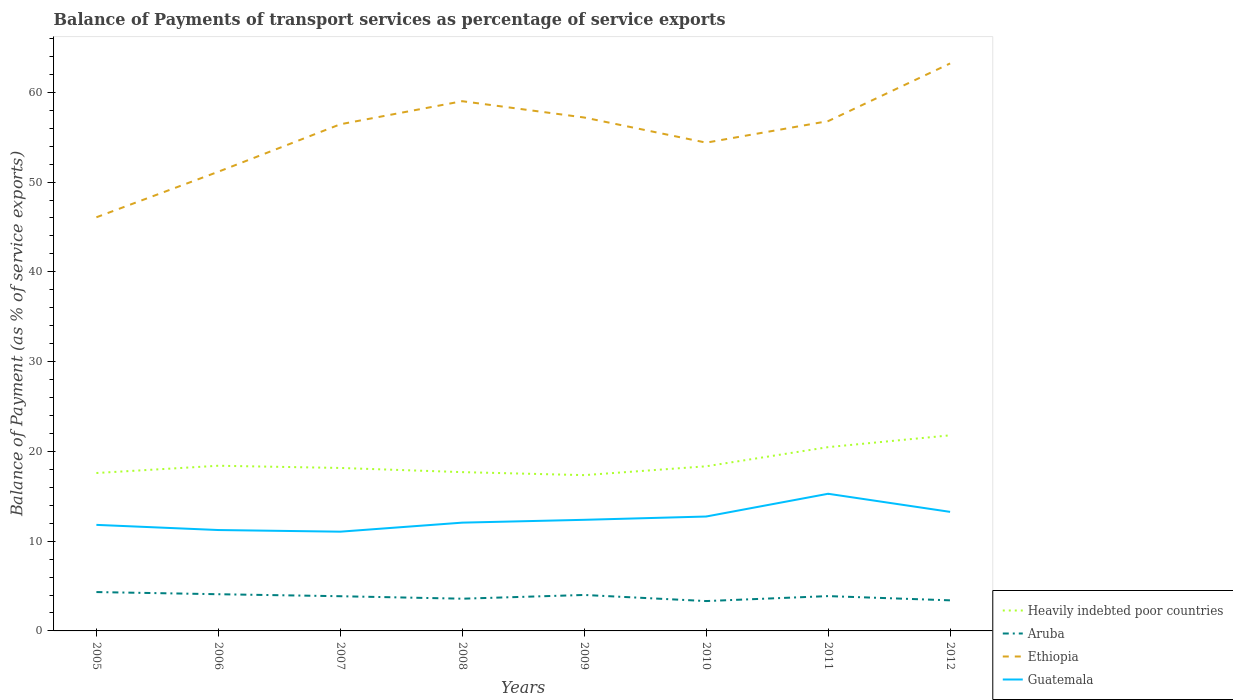Does the line corresponding to Guatemala intersect with the line corresponding to Heavily indebted poor countries?
Your answer should be very brief. No. Is the number of lines equal to the number of legend labels?
Your answer should be very brief. Yes. Across all years, what is the maximum balance of payments of transport services in Ethiopia?
Ensure brevity in your answer.  46.08. What is the total balance of payments of transport services in Aruba in the graph?
Make the answer very short. 0.08. What is the difference between the highest and the second highest balance of payments of transport services in Aruba?
Ensure brevity in your answer.  1. What is the difference between the highest and the lowest balance of payments of transport services in Guatemala?
Ensure brevity in your answer.  3. Is the balance of payments of transport services in Aruba strictly greater than the balance of payments of transport services in Ethiopia over the years?
Keep it short and to the point. Yes. What is the difference between two consecutive major ticks on the Y-axis?
Your answer should be compact. 10. Does the graph contain any zero values?
Offer a terse response. No. Where does the legend appear in the graph?
Keep it short and to the point. Bottom right. How are the legend labels stacked?
Offer a very short reply. Vertical. What is the title of the graph?
Your answer should be very brief. Balance of Payments of transport services as percentage of service exports. Does "Sweden" appear as one of the legend labels in the graph?
Keep it short and to the point. No. What is the label or title of the X-axis?
Keep it short and to the point. Years. What is the label or title of the Y-axis?
Your response must be concise. Balance of Payment (as % of service exports). What is the Balance of Payment (as % of service exports) in Heavily indebted poor countries in 2005?
Offer a very short reply. 17.59. What is the Balance of Payment (as % of service exports) of Aruba in 2005?
Keep it short and to the point. 4.33. What is the Balance of Payment (as % of service exports) of Ethiopia in 2005?
Make the answer very short. 46.08. What is the Balance of Payment (as % of service exports) of Guatemala in 2005?
Provide a succinct answer. 11.81. What is the Balance of Payment (as % of service exports) in Heavily indebted poor countries in 2006?
Give a very brief answer. 18.4. What is the Balance of Payment (as % of service exports) of Aruba in 2006?
Your answer should be very brief. 4.09. What is the Balance of Payment (as % of service exports) in Ethiopia in 2006?
Your answer should be compact. 51.16. What is the Balance of Payment (as % of service exports) in Guatemala in 2006?
Offer a very short reply. 11.24. What is the Balance of Payment (as % of service exports) in Heavily indebted poor countries in 2007?
Offer a terse response. 18.15. What is the Balance of Payment (as % of service exports) of Aruba in 2007?
Keep it short and to the point. 3.87. What is the Balance of Payment (as % of service exports) in Ethiopia in 2007?
Your response must be concise. 56.44. What is the Balance of Payment (as % of service exports) in Guatemala in 2007?
Give a very brief answer. 11.06. What is the Balance of Payment (as % of service exports) of Heavily indebted poor countries in 2008?
Give a very brief answer. 17.69. What is the Balance of Payment (as % of service exports) of Aruba in 2008?
Your answer should be compact. 3.59. What is the Balance of Payment (as % of service exports) of Ethiopia in 2008?
Offer a terse response. 59.01. What is the Balance of Payment (as % of service exports) in Guatemala in 2008?
Provide a short and direct response. 12.06. What is the Balance of Payment (as % of service exports) in Heavily indebted poor countries in 2009?
Your answer should be very brief. 17.36. What is the Balance of Payment (as % of service exports) of Aruba in 2009?
Your answer should be compact. 4.01. What is the Balance of Payment (as % of service exports) of Ethiopia in 2009?
Ensure brevity in your answer.  57.19. What is the Balance of Payment (as % of service exports) in Guatemala in 2009?
Offer a terse response. 12.38. What is the Balance of Payment (as % of service exports) of Heavily indebted poor countries in 2010?
Make the answer very short. 18.34. What is the Balance of Payment (as % of service exports) in Aruba in 2010?
Your response must be concise. 3.33. What is the Balance of Payment (as % of service exports) of Ethiopia in 2010?
Provide a succinct answer. 54.39. What is the Balance of Payment (as % of service exports) in Guatemala in 2010?
Your response must be concise. 12.74. What is the Balance of Payment (as % of service exports) of Heavily indebted poor countries in 2011?
Ensure brevity in your answer.  20.48. What is the Balance of Payment (as % of service exports) of Aruba in 2011?
Provide a succinct answer. 3.88. What is the Balance of Payment (as % of service exports) of Ethiopia in 2011?
Your response must be concise. 56.79. What is the Balance of Payment (as % of service exports) of Guatemala in 2011?
Your answer should be very brief. 15.28. What is the Balance of Payment (as % of service exports) of Heavily indebted poor countries in 2012?
Keep it short and to the point. 21.79. What is the Balance of Payment (as % of service exports) in Aruba in 2012?
Ensure brevity in your answer.  3.41. What is the Balance of Payment (as % of service exports) of Ethiopia in 2012?
Ensure brevity in your answer.  63.22. What is the Balance of Payment (as % of service exports) of Guatemala in 2012?
Provide a short and direct response. 13.26. Across all years, what is the maximum Balance of Payment (as % of service exports) in Heavily indebted poor countries?
Ensure brevity in your answer.  21.79. Across all years, what is the maximum Balance of Payment (as % of service exports) in Aruba?
Keep it short and to the point. 4.33. Across all years, what is the maximum Balance of Payment (as % of service exports) of Ethiopia?
Give a very brief answer. 63.22. Across all years, what is the maximum Balance of Payment (as % of service exports) in Guatemala?
Give a very brief answer. 15.28. Across all years, what is the minimum Balance of Payment (as % of service exports) in Heavily indebted poor countries?
Offer a terse response. 17.36. Across all years, what is the minimum Balance of Payment (as % of service exports) of Aruba?
Ensure brevity in your answer.  3.33. Across all years, what is the minimum Balance of Payment (as % of service exports) in Ethiopia?
Give a very brief answer. 46.08. Across all years, what is the minimum Balance of Payment (as % of service exports) in Guatemala?
Provide a short and direct response. 11.06. What is the total Balance of Payment (as % of service exports) in Heavily indebted poor countries in the graph?
Ensure brevity in your answer.  149.8. What is the total Balance of Payment (as % of service exports) in Aruba in the graph?
Ensure brevity in your answer.  30.49. What is the total Balance of Payment (as % of service exports) of Ethiopia in the graph?
Offer a very short reply. 444.28. What is the total Balance of Payment (as % of service exports) in Guatemala in the graph?
Offer a very short reply. 99.83. What is the difference between the Balance of Payment (as % of service exports) of Heavily indebted poor countries in 2005 and that in 2006?
Your answer should be very brief. -0.81. What is the difference between the Balance of Payment (as % of service exports) of Aruba in 2005 and that in 2006?
Offer a very short reply. 0.24. What is the difference between the Balance of Payment (as % of service exports) of Ethiopia in 2005 and that in 2006?
Your response must be concise. -5.08. What is the difference between the Balance of Payment (as % of service exports) of Guatemala in 2005 and that in 2006?
Make the answer very short. 0.58. What is the difference between the Balance of Payment (as % of service exports) in Heavily indebted poor countries in 2005 and that in 2007?
Provide a short and direct response. -0.56. What is the difference between the Balance of Payment (as % of service exports) in Aruba in 2005 and that in 2007?
Offer a terse response. 0.46. What is the difference between the Balance of Payment (as % of service exports) in Ethiopia in 2005 and that in 2007?
Keep it short and to the point. -10.36. What is the difference between the Balance of Payment (as % of service exports) in Guatemala in 2005 and that in 2007?
Your answer should be very brief. 0.76. What is the difference between the Balance of Payment (as % of service exports) of Heavily indebted poor countries in 2005 and that in 2008?
Provide a succinct answer. -0.1. What is the difference between the Balance of Payment (as % of service exports) of Aruba in 2005 and that in 2008?
Provide a short and direct response. 0.74. What is the difference between the Balance of Payment (as % of service exports) of Ethiopia in 2005 and that in 2008?
Offer a terse response. -12.93. What is the difference between the Balance of Payment (as % of service exports) of Guatemala in 2005 and that in 2008?
Ensure brevity in your answer.  -0.25. What is the difference between the Balance of Payment (as % of service exports) in Heavily indebted poor countries in 2005 and that in 2009?
Provide a short and direct response. 0.24. What is the difference between the Balance of Payment (as % of service exports) in Aruba in 2005 and that in 2009?
Your response must be concise. 0.32. What is the difference between the Balance of Payment (as % of service exports) in Ethiopia in 2005 and that in 2009?
Your answer should be very brief. -11.12. What is the difference between the Balance of Payment (as % of service exports) of Guatemala in 2005 and that in 2009?
Provide a succinct answer. -0.56. What is the difference between the Balance of Payment (as % of service exports) of Heavily indebted poor countries in 2005 and that in 2010?
Make the answer very short. -0.75. What is the difference between the Balance of Payment (as % of service exports) of Aruba in 2005 and that in 2010?
Provide a succinct answer. 1. What is the difference between the Balance of Payment (as % of service exports) in Ethiopia in 2005 and that in 2010?
Make the answer very short. -8.31. What is the difference between the Balance of Payment (as % of service exports) of Guatemala in 2005 and that in 2010?
Your answer should be very brief. -0.93. What is the difference between the Balance of Payment (as % of service exports) of Heavily indebted poor countries in 2005 and that in 2011?
Offer a very short reply. -2.88. What is the difference between the Balance of Payment (as % of service exports) in Aruba in 2005 and that in 2011?
Offer a very short reply. 0.45. What is the difference between the Balance of Payment (as % of service exports) of Ethiopia in 2005 and that in 2011?
Make the answer very short. -10.71. What is the difference between the Balance of Payment (as % of service exports) of Guatemala in 2005 and that in 2011?
Offer a terse response. -3.47. What is the difference between the Balance of Payment (as % of service exports) in Heavily indebted poor countries in 2005 and that in 2012?
Keep it short and to the point. -4.2. What is the difference between the Balance of Payment (as % of service exports) of Aruba in 2005 and that in 2012?
Offer a very short reply. 0.92. What is the difference between the Balance of Payment (as % of service exports) in Ethiopia in 2005 and that in 2012?
Your answer should be very brief. -17.14. What is the difference between the Balance of Payment (as % of service exports) of Guatemala in 2005 and that in 2012?
Make the answer very short. -1.45. What is the difference between the Balance of Payment (as % of service exports) of Heavily indebted poor countries in 2006 and that in 2007?
Your answer should be very brief. 0.25. What is the difference between the Balance of Payment (as % of service exports) in Aruba in 2006 and that in 2007?
Your answer should be compact. 0.22. What is the difference between the Balance of Payment (as % of service exports) of Ethiopia in 2006 and that in 2007?
Make the answer very short. -5.29. What is the difference between the Balance of Payment (as % of service exports) of Guatemala in 2006 and that in 2007?
Your answer should be compact. 0.18. What is the difference between the Balance of Payment (as % of service exports) of Heavily indebted poor countries in 2006 and that in 2008?
Provide a succinct answer. 0.71. What is the difference between the Balance of Payment (as % of service exports) in Aruba in 2006 and that in 2008?
Your answer should be very brief. 0.5. What is the difference between the Balance of Payment (as % of service exports) of Ethiopia in 2006 and that in 2008?
Ensure brevity in your answer.  -7.86. What is the difference between the Balance of Payment (as % of service exports) in Guatemala in 2006 and that in 2008?
Your response must be concise. -0.82. What is the difference between the Balance of Payment (as % of service exports) in Heavily indebted poor countries in 2006 and that in 2009?
Provide a short and direct response. 1.05. What is the difference between the Balance of Payment (as % of service exports) in Aruba in 2006 and that in 2009?
Make the answer very short. 0.08. What is the difference between the Balance of Payment (as % of service exports) in Ethiopia in 2006 and that in 2009?
Ensure brevity in your answer.  -6.04. What is the difference between the Balance of Payment (as % of service exports) of Guatemala in 2006 and that in 2009?
Make the answer very short. -1.14. What is the difference between the Balance of Payment (as % of service exports) in Heavily indebted poor countries in 2006 and that in 2010?
Make the answer very short. 0.06. What is the difference between the Balance of Payment (as % of service exports) in Aruba in 2006 and that in 2010?
Offer a very short reply. 0.76. What is the difference between the Balance of Payment (as % of service exports) in Ethiopia in 2006 and that in 2010?
Give a very brief answer. -3.24. What is the difference between the Balance of Payment (as % of service exports) in Guatemala in 2006 and that in 2010?
Provide a short and direct response. -1.51. What is the difference between the Balance of Payment (as % of service exports) in Heavily indebted poor countries in 2006 and that in 2011?
Your answer should be very brief. -2.07. What is the difference between the Balance of Payment (as % of service exports) in Aruba in 2006 and that in 2011?
Make the answer very short. 0.21. What is the difference between the Balance of Payment (as % of service exports) in Ethiopia in 2006 and that in 2011?
Offer a very short reply. -5.64. What is the difference between the Balance of Payment (as % of service exports) of Guatemala in 2006 and that in 2011?
Provide a succinct answer. -4.04. What is the difference between the Balance of Payment (as % of service exports) in Heavily indebted poor countries in 2006 and that in 2012?
Offer a terse response. -3.39. What is the difference between the Balance of Payment (as % of service exports) of Aruba in 2006 and that in 2012?
Provide a succinct answer. 0.68. What is the difference between the Balance of Payment (as % of service exports) of Ethiopia in 2006 and that in 2012?
Offer a very short reply. -12.06. What is the difference between the Balance of Payment (as % of service exports) in Guatemala in 2006 and that in 2012?
Your answer should be compact. -2.02. What is the difference between the Balance of Payment (as % of service exports) in Heavily indebted poor countries in 2007 and that in 2008?
Your answer should be very brief. 0.47. What is the difference between the Balance of Payment (as % of service exports) in Aruba in 2007 and that in 2008?
Offer a terse response. 0.28. What is the difference between the Balance of Payment (as % of service exports) in Ethiopia in 2007 and that in 2008?
Provide a succinct answer. -2.57. What is the difference between the Balance of Payment (as % of service exports) in Guatemala in 2007 and that in 2008?
Your answer should be compact. -1.01. What is the difference between the Balance of Payment (as % of service exports) in Heavily indebted poor countries in 2007 and that in 2009?
Ensure brevity in your answer.  0.8. What is the difference between the Balance of Payment (as % of service exports) in Aruba in 2007 and that in 2009?
Make the answer very short. -0.14. What is the difference between the Balance of Payment (as % of service exports) in Ethiopia in 2007 and that in 2009?
Give a very brief answer. -0.75. What is the difference between the Balance of Payment (as % of service exports) of Guatemala in 2007 and that in 2009?
Ensure brevity in your answer.  -1.32. What is the difference between the Balance of Payment (as % of service exports) of Heavily indebted poor countries in 2007 and that in 2010?
Your response must be concise. -0.18. What is the difference between the Balance of Payment (as % of service exports) in Aruba in 2007 and that in 2010?
Provide a succinct answer. 0.54. What is the difference between the Balance of Payment (as % of service exports) of Ethiopia in 2007 and that in 2010?
Your answer should be very brief. 2.05. What is the difference between the Balance of Payment (as % of service exports) of Guatemala in 2007 and that in 2010?
Your response must be concise. -1.69. What is the difference between the Balance of Payment (as % of service exports) of Heavily indebted poor countries in 2007 and that in 2011?
Provide a short and direct response. -2.32. What is the difference between the Balance of Payment (as % of service exports) of Aruba in 2007 and that in 2011?
Your response must be concise. -0.01. What is the difference between the Balance of Payment (as % of service exports) of Ethiopia in 2007 and that in 2011?
Give a very brief answer. -0.35. What is the difference between the Balance of Payment (as % of service exports) of Guatemala in 2007 and that in 2011?
Provide a short and direct response. -4.22. What is the difference between the Balance of Payment (as % of service exports) in Heavily indebted poor countries in 2007 and that in 2012?
Make the answer very short. -3.64. What is the difference between the Balance of Payment (as % of service exports) in Aruba in 2007 and that in 2012?
Your response must be concise. 0.46. What is the difference between the Balance of Payment (as % of service exports) in Ethiopia in 2007 and that in 2012?
Provide a succinct answer. -6.77. What is the difference between the Balance of Payment (as % of service exports) in Guatemala in 2007 and that in 2012?
Your answer should be compact. -2.21. What is the difference between the Balance of Payment (as % of service exports) of Heavily indebted poor countries in 2008 and that in 2009?
Provide a short and direct response. 0.33. What is the difference between the Balance of Payment (as % of service exports) in Aruba in 2008 and that in 2009?
Give a very brief answer. -0.42. What is the difference between the Balance of Payment (as % of service exports) in Ethiopia in 2008 and that in 2009?
Provide a short and direct response. 1.82. What is the difference between the Balance of Payment (as % of service exports) of Guatemala in 2008 and that in 2009?
Keep it short and to the point. -0.31. What is the difference between the Balance of Payment (as % of service exports) in Heavily indebted poor countries in 2008 and that in 2010?
Provide a succinct answer. -0.65. What is the difference between the Balance of Payment (as % of service exports) in Aruba in 2008 and that in 2010?
Ensure brevity in your answer.  0.26. What is the difference between the Balance of Payment (as % of service exports) in Ethiopia in 2008 and that in 2010?
Provide a short and direct response. 4.62. What is the difference between the Balance of Payment (as % of service exports) in Guatemala in 2008 and that in 2010?
Your response must be concise. -0.68. What is the difference between the Balance of Payment (as % of service exports) of Heavily indebted poor countries in 2008 and that in 2011?
Make the answer very short. -2.79. What is the difference between the Balance of Payment (as % of service exports) in Aruba in 2008 and that in 2011?
Your answer should be compact. -0.29. What is the difference between the Balance of Payment (as % of service exports) of Ethiopia in 2008 and that in 2011?
Your response must be concise. 2.22. What is the difference between the Balance of Payment (as % of service exports) of Guatemala in 2008 and that in 2011?
Provide a succinct answer. -3.22. What is the difference between the Balance of Payment (as % of service exports) in Heavily indebted poor countries in 2008 and that in 2012?
Provide a succinct answer. -4.1. What is the difference between the Balance of Payment (as % of service exports) in Aruba in 2008 and that in 2012?
Provide a short and direct response. 0.18. What is the difference between the Balance of Payment (as % of service exports) of Ethiopia in 2008 and that in 2012?
Ensure brevity in your answer.  -4.2. What is the difference between the Balance of Payment (as % of service exports) of Guatemala in 2008 and that in 2012?
Keep it short and to the point. -1.2. What is the difference between the Balance of Payment (as % of service exports) in Heavily indebted poor countries in 2009 and that in 2010?
Your response must be concise. -0.98. What is the difference between the Balance of Payment (as % of service exports) of Aruba in 2009 and that in 2010?
Provide a short and direct response. 0.68. What is the difference between the Balance of Payment (as % of service exports) in Ethiopia in 2009 and that in 2010?
Your answer should be very brief. 2.8. What is the difference between the Balance of Payment (as % of service exports) in Guatemala in 2009 and that in 2010?
Keep it short and to the point. -0.37. What is the difference between the Balance of Payment (as % of service exports) of Heavily indebted poor countries in 2009 and that in 2011?
Make the answer very short. -3.12. What is the difference between the Balance of Payment (as % of service exports) of Aruba in 2009 and that in 2011?
Keep it short and to the point. 0.13. What is the difference between the Balance of Payment (as % of service exports) of Ethiopia in 2009 and that in 2011?
Your answer should be compact. 0.4. What is the difference between the Balance of Payment (as % of service exports) of Guatemala in 2009 and that in 2011?
Your answer should be compact. -2.9. What is the difference between the Balance of Payment (as % of service exports) in Heavily indebted poor countries in 2009 and that in 2012?
Offer a very short reply. -4.43. What is the difference between the Balance of Payment (as % of service exports) of Aruba in 2009 and that in 2012?
Make the answer very short. 0.6. What is the difference between the Balance of Payment (as % of service exports) of Ethiopia in 2009 and that in 2012?
Make the answer very short. -6.02. What is the difference between the Balance of Payment (as % of service exports) of Guatemala in 2009 and that in 2012?
Your answer should be compact. -0.89. What is the difference between the Balance of Payment (as % of service exports) in Heavily indebted poor countries in 2010 and that in 2011?
Your answer should be very brief. -2.14. What is the difference between the Balance of Payment (as % of service exports) in Aruba in 2010 and that in 2011?
Ensure brevity in your answer.  -0.55. What is the difference between the Balance of Payment (as % of service exports) of Ethiopia in 2010 and that in 2011?
Provide a short and direct response. -2.4. What is the difference between the Balance of Payment (as % of service exports) of Guatemala in 2010 and that in 2011?
Provide a short and direct response. -2.53. What is the difference between the Balance of Payment (as % of service exports) in Heavily indebted poor countries in 2010 and that in 2012?
Offer a terse response. -3.45. What is the difference between the Balance of Payment (as % of service exports) in Aruba in 2010 and that in 2012?
Offer a very short reply. -0.08. What is the difference between the Balance of Payment (as % of service exports) of Ethiopia in 2010 and that in 2012?
Your response must be concise. -8.82. What is the difference between the Balance of Payment (as % of service exports) in Guatemala in 2010 and that in 2012?
Your answer should be very brief. -0.52. What is the difference between the Balance of Payment (as % of service exports) of Heavily indebted poor countries in 2011 and that in 2012?
Make the answer very short. -1.31. What is the difference between the Balance of Payment (as % of service exports) of Aruba in 2011 and that in 2012?
Give a very brief answer. 0.47. What is the difference between the Balance of Payment (as % of service exports) in Ethiopia in 2011 and that in 2012?
Give a very brief answer. -6.42. What is the difference between the Balance of Payment (as % of service exports) in Guatemala in 2011 and that in 2012?
Offer a very short reply. 2.02. What is the difference between the Balance of Payment (as % of service exports) of Heavily indebted poor countries in 2005 and the Balance of Payment (as % of service exports) of Aruba in 2006?
Your response must be concise. 13.5. What is the difference between the Balance of Payment (as % of service exports) of Heavily indebted poor countries in 2005 and the Balance of Payment (as % of service exports) of Ethiopia in 2006?
Make the answer very short. -33.56. What is the difference between the Balance of Payment (as % of service exports) in Heavily indebted poor countries in 2005 and the Balance of Payment (as % of service exports) in Guatemala in 2006?
Your response must be concise. 6.35. What is the difference between the Balance of Payment (as % of service exports) of Aruba in 2005 and the Balance of Payment (as % of service exports) of Ethiopia in 2006?
Your response must be concise. -46.83. What is the difference between the Balance of Payment (as % of service exports) of Aruba in 2005 and the Balance of Payment (as % of service exports) of Guatemala in 2006?
Your response must be concise. -6.91. What is the difference between the Balance of Payment (as % of service exports) in Ethiopia in 2005 and the Balance of Payment (as % of service exports) in Guatemala in 2006?
Provide a succinct answer. 34.84. What is the difference between the Balance of Payment (as % of service exports) in Heavily indebted poor countries in 2005 and the Balance of Payment (as % of service exports) in Aruba in 2007?
Keep it short and to the point. 13.73. What is the difference between the Balance of Payment (as % of service exports) in Heavily indebted poor countries in 2005 and the Balance of Payment (as % of service exports) in Ethiopia in 2007?
Offer a terse response. -38.85. What is the difference between the Balance of Payment (as % of service exports) of Heavily indebted poor countries in 2005 and the Balance of Payment (as % of service exports) of Guatemala in 2007?
Your response must be concise. 6.53. What is the difference between the Balance of Payment (as % of service exports) of Aruba in 2005 and the Balance of Payment (as % of service exports) of Ethiopia in 2007?
Make the answer very short. -52.11. What is the difference between the Balance of Payment (as % of service exports) in Aruba in 2005 and the Balance of Payment (as % of service exports) in Guatemala in 2007?
Keep it short and to the point. -6.73. What is the difference between the Balance of Payment (as % of service exports) of Ethiopia in 2005 and the Balance of Payment (as % of service exports) of Guatemala in 2007?
Make the answer very short. 35.02. What is the difference between the Balance of Payment (as % of service exports) in Heavily indebted poor countries in 2005 and the Balance of Payment (as % of service exports) in Aruba in 2008?
Your response must be concise. 14. What is the difference between the Balance of Payment (as % of service exports) of Heavily indebted poor countries in 2005 and the Balance of Payment (as % of service exports) of Ethiopia in 2008?
Keep it short and to the point. -41.42. What is the difference between the Balance of Payment (as % of service exports) of Heavily indebted poor countries in 2005 and the Balance of Payment (as % of service exports) of Guatemala in 2008?
Provide a succinct answer. 5.53. What is the difference between the Balance of Payment (as % of service exports) of Aruba in 2005 and the Balance of Payment (as % of service exports) of Ethiopia in 2008?
Your answer should be compact. -54.68. What is the difference between the Balance of Payment (as % of service exports) in Aruba in 2005 and the Balance of Payment (as % of service exports) in Guatemala in 2008?
Ensure brevity in your answer.  -7.73. What is the difference between the Balance of Payment (as % of service exports) in Ethiopia in 2005 and the Balance of Payment (as % of service exports) in Guatemala in 2008?
Offer a terse response. 34.02. What is the difference between the Balance of Payment (as % of service exports) of Heavily indebted poor countries in 2005 and the Balance of Payment (as % of service exports) of Aruba in 2009?
Give a very brief answer. 13.58. What is the difference between the Balance of Payment (as % of service exports) of Heavily indebted poor countries in 2005 and the Balance of Payment (as % of service exports) of Ethiopia in 2009?
Give a very brief answer. -39.6. What is the difference between the Balance of Payment (as % of service exports) in Heavily indebted poor countries in 2005 and the Balance of Payment (as % of service exports) in Guatemala in 2009?
Offer a terse response. 5.21. What is the difference between the Balance of Payment (as % of service exports) of Aruba in 2005 and the Balance of Payment (as % of service exports) of Ethiopia in 2009?
Ensure brevity in your answer.  -52.87. What is the difference between the Balance of Payment (as % of service exports) in Aruba in 2005 and the Balance of Payment (as % of service exports) in Guatemala in 2009?
Give a very brief answer. -8.05. What is the difference between the Balance of Payment (as % of service exports) of Ethiopia in 2005 and the Balance of Payment (as % of service exports) of Guatemala in 2009?
Keep it short and to the point. 33.7. What is the difference between the Balance of Payment (as % of service exports) in Heavily indebted poor countries in 2005 and the Balance of Payment (as % of service exports) in Aruba in 2010?
Make the answer very short. 14.26. What is the difference between the Balance of Payment (as % of service exports) of Heavily indebted poor countries in 2005 and the Balance of Payment (as % of service exports) of Ethiopia in 2010?
Provide a succinct answer. -36.8. What is the difference between the Balance of Payment (as % of service exports) in Heavily indebted poor countries in 2005 and the Balance of Payment (as % of service exports) in Guatemala in 2010?
Keep it short and to the point. 4.85. What is the difference between the Balance of Payment (as % of service exports) of Aruba in 2005 and the Balance of Payment (as % of service exports) of Ethiopia in 2010?
Your response must be concise. -50.06. What is the difference between the Balance of Payment (as % of service exports) of Aruba in 2005 and the Balance of Payment (as % of service exports) of Guatemala in 2010?
Your answer should be very brief. -8.42. What is the difference between the Balance of Payment (as % of service exports) in Ethiopia in 2005 and the Balance of Payment (as % of service exports) in Guatemala in 2010?
Provide a succinct answer. 33.33. What is the difference between the Balance of Payment (as % of service exports) in Heavily indebted poor countries in 2005 and the Balance of Payment (as % of service exports) in Aruba in 2011?
Ensure brevity in your answer.  13.71. What is the difference between the Balance of Payment (as % of service exports) of Heavily indebted poor countries in 2005 and the Balance of Payment (as % of service exports) of Ethiopia in 2011?
Give a very brief answer. -39.2. What is the difference between the Balance of Payment (as % of service exports) in Heavily indebted poor countries in 2005 and the Balance of Payment (as % of service exports) in Guatemala in 2011?
Make the answer very short. 2.31. What is the difference between the Balance of Payment (as % of service exports) in Aruba in 2005 and the Balance of Payment (as % of service exports) in Ethiopia in 2011?
Offer a terse response. -52.46. What is the difference between the Balance of Payment (as % of service exports) in Aruba in 2005 and the Balance of Payment (as % of service exports) in Guatemala in 2011?
Ensure brevity in your answer.  -10.95. What is the difference between the Balance of Payment (as % of service exports) in Ethiopia in 2005 and the Balance of Payment (as % of service exports) in Guatemala in 2011?
Provide a short and direct response. 30.8. What is the difference between the Balance of Payment (as % of service exports) in Heavily indebted poor countries in 2005 and the Balance of Payment (as % of service exports) in Aruba in 2012?
Your answer should be compact. 14.18. What is the difference between the Balance of Payment (as % of service exports) in Heavily indebted poor countries in 2005 and the Balance of Payment (as % of service exports) in Ethiopia in 2012?
Keep it short and to the point. -45.62. What is the difference between the Balance of Payment (as % of service exports) of Heavily indebted poor countries in 2005 and the Balance of Payment (as % of service exports) of Guatemala in 2012?
Your response must be concise. 4.33. What is the difference between the Balance of Payment (as % of service exports) in Aruba in 2005 and the Balance of Payment (as % of service exports) in Ethiopia in 2012?
Provide a short and direct response. -58.89. What is the difference between the Balance of Payment (as % of service exports) in Aruba in 2005 and the Balance of Payment (as % of service exports) in Guatemala in 2012?
Give a very brief answer. -8.93. What is the difference between the Balance of Payment (as % of service exports) of Ethiopia in 2005 and the Balance of Payment (as % of service exports) of Guatemala in 2012?
Keep it short and to the point. 32.82. What is the difference between the Balance of Payment (as % of service exports) in Heavily indebted poor countries in 2006 and the Balance of Payment (as % of service exports) in Aruba in 2007?
Give a very brief answer. 14.54. What is the difference between the Balance of Payment (as % of service exports) in Heavily indebted poor countries in 2006 and the Balance of Payment (as % of service exports) in Ethiopia in 2007?
Give a very brief answer. -38.04. What is the difference between the Balance of Payment (as % of service exports) in Heavily indebted poor countries in 2006 and the Balance of Payment (as % of service exports) in Guatemala in 2007?
Offer a very short reply. 7.35. What is the difference between the Balance of Payment (as % of service exports) of Aruba in 2006 and the Balance of Payment (as % of service exports) of Ethiopia in 2007?
Provide a short and direct response. -52.35. What is the difference between the Balance of Payment (as % of service exports) in Aruba in 2006 and the Balance of Payment (as % of service exports) in Guatemala in 2007?
Keep it short and to the point. -6.97. What is the difference between the Balance of Payment (as % of service exports) of Ethiopia in 2006 and the Balance of Payment (as % of service exports) of Guatemala in 2007?
Your answer should be compact. 40.1. What is the difference between the Balance of Payment (as % of service exports) in Heavily indebted poor countries in 2006 and the Balance of Payment (as % of service exports) in Aruba in 2008?
Your response must be concise. 14.81. What is the difference between the Balance of Payment (as % of service exports) of Heavily indebted poor countries in 2006 and the Balance of Payment (as % of service exports) of Ethiopia in 2008?
Your answer should be compact. -40.61. What is the difference between the Balance of Payment (as % of service exports) of Heavily indebted poor countries in 2006 and the Balance of Payment (as % of service exports) of Guatemala in 2008?
Keep it short and to the point. 6.34. What is the difference between the Balance of Payment (as % of service exports) in Aruba in 2006 and the Balance of Payment (as % of service exports) in Ethiopia in 2008?
Your answer should be very brief. -54.92. What is the difference between the Balance of Payment (as % of service exports) in Aruba in 2006 and the Balance of Payment (as % of service exports) in Guatemala in 2008?
Ensure brevity in your answer.  -7.97. What is the difference between the Balance of Payment (as % of service exports) of Ethiopia in 2006 and the Balance of Payment (as % of service exports) of Guatemala in 2008?
Provide a short and direct response. 39.09. What is the difference between the Balance of Payment (as % of service exports) of Heavily indebted poor countries in 2006 and the Balance of Payment (as % of service exports) of Aruba in 2009?
Make the answer very short. 14.4. What is the difference between the Balance of Payment (as % of service exports) in Heavily indebted poor countries in 2006 and the Balance of Payment (as % of service exports) in Ethiopia in 2009?
Make the answer very short. -38.79. What is the difference between the Balance of Payment (as % of service exports) in Heavily indebted poor countries in 2006 and the Balance of Payment (as % of service exports) in Guatemala in 2009?
Your response must be concise. 6.02. What is the difference between the Balance of Payment (as % of service exports) in Aruba in 2006 and the Balance of Payment (as % of service exports) in Ethiopia in 2009?
Offer a terse response. -53.11. What is the difference between the Balance of Payment (as % of service exports) of Aruba in 2006 and the Balance of Payment (as % of service exports) of Guatemala in 2009?
Your answer should be very brief. -8.29. What is the difference between the Balance of Payment (as % of service exports) in Ethiopia in 2006 and the Balance of Payment (as % of service exports) in Guatemala in 2009?
Provide a short and direct response. 38.78. What is the difference between the Balance of Payment (as % of service exports) in Heavily indebted poor countries in 2006 and the Balance of Payment (as % of service exports) in Aruba in 2010?
Provide a short and direct response. 15.07. What is the difference between the Balance of Payment (as % of service exports) of Heavily indebted poor countries in 2006 and the Balance of Payment (as % of service exports) of Ethiopia in 2010?
Keep it short and to the point. -35.99. What is the difference between the Balance of Payment (as % of service exports) of Heavily indebted poor countries in 2006 and the Balance of Payment (as % of service exports) of Guatemala in 2010?
Your answer should be very brief. 5.66. What is the difference between the Balance of Payment (as % of service exports) in Aruba in 2006 and the Balance of Payment (as % of service exports) in Ethiopia in 2010?
Your answer should be very brief. -50.3. What is the difference between the Balance of Payment (as % of service exports) of Aruba in 2006 and the Balance of Payment (as % of service exports) of Guatemala in 2010?
Ensure brevity in your answer.  -8.66. What is the difference between the Balance of Payment (as % of service exports) of Ethiopia in 2006 and the Balance of Payment (as % of service exports) of Guatemala in 2010?
Offer a terse response. 38.41. What is the difference between the Balance of Payment (as % of service exports) in Heavily indebted poor countries in 2006 and the Balance of Payment (as % of service exports) in Aruba in 2011?
Ensure brevity in your answer.  14.52. What is the difference between the Balance of Payment (as % of service exports) in Heavily indebted poor countries in 2006 and the Balance of Payment (as % of service exports) in Ethiopia in 2011?
Offer a terse response. -38.39. What is the difference between the Balance of Payment (as % of service exports) in Heavily indebted poor countries in 2006 and the Balance of Payment (as % of service exports) in Guatemala in 2011?
Your answer should be compact. 3.12. What is the difference between the Balance of Payment (as % of service exports) in Aruba in 2006 and the Balance of Payment (as % of service exports) in Ethiopia in 2011?
Offer a very short reply. -52.7. What is the difference between the Balance of Payment (as % of service exports) of Aruba in 2006 and the Balance of Payment (as % of service exports) of Guatemala in 2011?
Your answer should be very brief. -11.19. What is the difference between the Balance of Payment (as % of service exports) of Ethiopia in 2006 and the Balance of Payment (as % of service exports) of Guatemala in 2011?
Your response must be concise. 35.88. What is the difference between the Balance of Payment (as % of service exports) of Heavily indebted poor countries in 2006 and the Balance of Payment (as % of service exports) of Aruba in 2012?
Ensure brevity in your answer.  14.99. What is the difference between the Balance of Payment (as % of service exports) of Heavily indebted poor countries in 2006 and the Balance of Payment (as % of service exports) of Ethiopia in 2012?
Offer a terse response. -44.81. What is the difference between the Balance of Payment (as % of service exports) in Heavily indebted poor countries in 2006 and the Balance of Payment (as % of service exports) in Guatemala in 2012?
Provide a short and direct response. 5.14. What is the difference between the Balance of Payment (as % of service exports) in Aruba in 2006 and the Balance of Payment (as % of service exports) in Ethiopia in 2012?
Offer a terse response. -59.13. What is the difference between the Balance of Payment (as % of service exports) in Aruba in 2006 and the Balance of Payment (as % of service exports) in Guatemala in 2012?
Offer a very short reply. -9.17. What is the difference between the Balance of Payment (as % of service exports) in Ethiopia in 2006 and the Balance of Payment (as % of service exports) in Guatemala in 2012?
Offer a terse response. 37.89. What is the difference between the Balance of Payment (as % of service exports) of Heavily indebted poor countries in 2007 and the Balance of Payment (as % of service exports) of Aruba in 2008?
Your answer should be compact. 14.56. What is the difference between the Balance of Payment (as % of service exports) in Heavily indebted poor countries in 2007 and the Balance of Payment (as % of service exports) in Ethiopia in 2008?
Ensure brevity in your answer.  -40.86. What is the difference between the Balance of Payment (as % of service exports) in Heavily indebted poor countries in 2007 and the Balance of Payment (as % of service exports) in Guatemala in 2008?
Give a very brief answer. 6.09. What is the difference between the Balance of Payment (as % of service exports) of Aruba in 2007 and the Balance of Payment (as % of service exports) of Ethiopia in 2008?
Make the answer very short. -55.15. What is the difference between the Balance of Payment (as % of service exports) of Aruba in 2007 and the Balance of Payment (as % of service exports) of Guatemala in 2008?
Your response must be concise. -8.2. What is the difference between the Balance of Payment (as % of service exports) in Ethiopia in 2007 and the Balance of Payment (as % of service exports) in Guatemala in 2008?
Offer a very short reply. 44.38. What is the difference between the Balance of Payment (as % of service exports) in Heavily indebted poor countries in 2007 and the Balance of Payment (as % of service exports) in Aruba in 2009?
Your answer should be very brief. 14.15. What is the difference between the Balance of Payment (as % of service exports) of Heavily indebted poor countries in 2007 and the Balance of Payment (as % of service exports) of Ethiopia in 2009?
Offer a very short reply. -39.04. What is the difference between the Balance of Payment (as % of service exports) in Heavily indebted poor countries in 2007 and the Balance of Payment (as % of service exports) in Guatemala in 2009?
Make the answer very short. 5.78. What is the difference between the Balance of Payment (as % of service exports) in Aruba in 2007 and the Balance of Payment (as % of service exports) in Ethiopia in 2009?
Your answer should be compact. -53.33. What is the difference between the Balance of Payment (as % of service exports) in Aruba in 2007 and the Balance of Payment (as % of service exports) in Guatemala in 2009?
Ensure brevity in your answer.  -8.51. What is the difference between the Balance of Payment (as % of service exports) in Ethiopia in 2007 and the Balance of Payment (as % of service exports) in Guatemala in 2009?
Your answer should be very brief. 44.06. What is the difference between the Balance of Payment (as % of service exports) of Heavily indebted poor countries in 2007 and the Balance of Payment (as % of service exports) of Aruba in 2010?
Offer a very short reply. 14.83. What is the difference between the Balance of Payment (as % of service exports) in Heavily indebted poor countries in 2007 and the Balance of Payment (as % of service exports) in Ethiopia in 2010?
Provide a short and direct response. -36.24. What is the difference between the Balance of Payment (as % of service exports) in Heavily indebted poor countries in 2007 and the Balance of Payment (as % of service exports) in Guatemala in 2010?
Offer a terse response. 5.41. What is the difference between the Balance of Payment (as % of service exports) of Aruba in 2007 and the Balance of Payment (as % of service exports) of Ethiopia in 2010?
Give a very brief answer. -50.53. What is the difference between the Balance of Payment (as % of service exports) in Aruba in 2007 and the Balance of Payment (as % of service exports) in Guatemala in 2010?
Offer a very short reply. -8.88. What is the difference between the Balance of Payment (as % of service exports) of Ethiopia in 2007 and the Balance of Payment (as % of service exports) of Guatemala in 2010?
Your response must be concise. 43.7. What is the difference between the Balance of Payment (as % of service exports) of Heavily indebted poor countries in 2007 and the Balance of Payment (as % of service exports) of Aruba in 2011?
Provide a short and direct response. 14.28. What is the difference between the Balance of Payment (as % of service exports) in Heavily indebted poor countries in 2007 and the Balance of Payment (as % of service exports) in Ethiopia in 2011?
Keep it short and to the point. -38.64. What is the difference between the Balance of Payment (as % of service exports) of Heavily indebted poor countries in 2007 and the Balance of Payment (as % of service exports) of Guatemala in 2011?
Your answer should be very brief. 2.88. What is the difference between the Balance of Payment (as % of service exports) in Aruba in 2007 and the Balance of Payment (as % of service exports) in Ethiopia in 2011?
Your answer should be compact. -52.93. What is the difference between the Balance of Payment (as % of service exports) in Aruba in 2007 and the Balance of Payment (as % of service exports) in Guatemala in 2011?
Offer a terse response. -11.41. What is the difference between the Balance of Payment (as % of service exports) in Ethiopia in 2007 and the Balance of Payment (as % of service exports) in Guatemala in 2011?
Your answer should be very brief. 41.16. What is the difference between the Balance of Payment (as % of service exports) of Heavily indebted poor countries in 2007 and the Balance of Payment (as % of service exports) of Aruba in 2012?
Give a very brief answer. 14.75. What is the difference between the Balance of Payment (as % of service exports) in Heavily indebted poor countries in 2007 and the Balance of Payment (as % of service exports) in Ethiopia in 2012?
Offer a very short reply. -45.06. What is the difference between the Balance of Payment (as % of service exports) of Heavily indebted poor countries in 2007 and the Balance of Payment (as % of service exports) of Guatemala in 2012?
Offer a very short reply. 4.89. What is the difference between the Balance of Payment (as % of service exports) of Aruba in 2007 and the Balance of Payment (as % of service exports) of Ethiopia in 2012?
Your answer should be very brief. -59.35. What is the difference between the Balance of Payment (as % of service exports) in Aruba in 2007 and the Balance of Payment (as % of service exports) in Guatemala in 2012?
Give a very brief answer. -9.4. What is the difference between the Balance of Payment (as % of service exports) of Ethiopia in 2007 and the Balance of Payment (as % of service exports) of Guatemala in 2012?
Provide a succinct answer. 43.18. What is the difference between the Balance of Payment (as % of service exports) of Heavily indebted poor countries in 2008 and the Balance of Payment (as % of service exports) of Aruba in 2009?
Your answer should be compact. 13.68. What is the difference between the Balance of Payment (as % of service exports) of Heavily indebted poor countries in 2008 and the Balance of Payment (as % of service exports) of Ethiopia in 2009?
Make the answer very short. -39.51. What is the difference between the Balance of Payment (as % of service exports) in Heavily indebted poor countries in 2008 and the Balance of Payment (as % of service exports) in Guatemala in 2009?
Offer a terse response. 5.31. What is the difference between the Balance of Payment (as % of service exports) of Aruba in 2008 and the Balance of Payment (as % of service exports) of Ethiopia in 2009?
Keep it short and to the point. -53.61. What is the difference between the Balance of Payment (as % of service exports) of Aruba in 2008 and the Balance of Payment (as % of service exports) of Guatemala in 2009?
Give a very brief answer. -8.79. What is the difference between the Balance of Payment (as % of service exports) in Ethiopia in 2008 and the Balance of Payment (as % of service exports) in Guatemala in 2009?
Provide a succinct answer. 46.64. What is the difference between the Balance of Payment (as % of service exports) in Heavily indebted poor countries in 2008 and the Balance of Payment (as % of service exports) in Aruba in 2010?
Provide a succinct answer. 14.36. What is the difference between the Balance of Payment (as % of service exports) in Heavily indebted poor countries in 2008 and the Balance of Payment (as % of service exports) in Ethiopia in 2010?
Provide a short and direct response. -36.7. What is the difference between the Balance of Payment (as % of service exports) of Heavily indebted poor countries in 2008 and the Balance of Payment (as % of service exports) of Guatemala in 2010?
Offer a terse response. 4.95. What is the difference between the Balance of Payment (as % of service exports) in Aruba in 2008 and the Balance of Payment (as % of service exports) in Ethiopia in 2010?
Your answer should be very brief. -50.8. What is the difference between the Balance of Payment (as % of service exports) of Aruba in 2008 and the Balance of Payment (as % of service exports) of Guatemala in 2010?
Your answer should be compact. -9.16. What is the difference between the Balance of Payment (as % of service exports) of Ethiopia in 2008 and the Balance of Payment (as % of service exports) of Guatemala in 2010?
Provide a succinct answer. 46.27. What is the difference between the Balance of Payment (as % of service exports) in Heavily indebted poor countries in 2008 and the Balance of Payment (as % of service exports) in Aruba in 2011?
Keep it short and to the point. 13.81. What is the difference between the Balance of Payment (as % of service exports) of Heavily indebted poor countries in 2008 and the Balance of Payment (as % of service exports) of Ethiopia in 2011?
Give a very brief answer. -39.1. What is the difference between the Balance of Payment (as % of service exports) in Heavily indebted poor countries in 2008 and the Balance of Payment (as % of service exports) in Guatemala in 2011?
Your response must be concise. 2.41. What is the difference between the Balance of Payment (as % of service exports) of Aruba in 2008 and the Balance of Payment (as % of service exports) of Ethiopia in 2011?
Your answer should be very brief. -53.2. What is the difference between the Balance of Payment (as % of service exports) in Aruba in 2008 and the Balance of Payment (as % of service exports) in Guatemala in 2011?
Offer a very short reply. -11.69. What is the difference between the Balance of Payment (as % of service exports) in Ethiopia in 2008 and the Balance of Payment (as % of service exports) in Guatemala in 2011?
Your response must be concise. 43.73. What is the difference between the Balance of Payment (as % of service exports) of Heavily indebted poor countries in 2008 and the Balance of Payment (as % of service exports) of Aruba in 2012?
Provide a short and direct response. 14.28. What is the difference between the Balance of Payment (as % of service exports) of Heavily indebted poor countries in 2008 and the Balance of Payment (as % of service exports) of Ethiopia in 2012?
Your answer should be very brief. -45.53. What is the difference between the Balance of Payment (as % of service exports) in Heavily indebted poor countries in 2008 and the Balance of Payment (as % of service exports) in Guatemala in 2012?
Provide a succinct answer. 4.43. What is the difference between the Balance of Payment (as % of service exports) in Aruba in 2008 and the Balance of Payment (as % of service exports) in Ethiopia in 2012?
Your answer should be very brief. -59.63. What is the difference between the Balance of Payment (as % of service exports) in Aruba in 2008 and the Balance of Payment (as % of service exports) in Guatemala in 2012?
Offer a terse response. -9.67. What is the difference between the Balance of Payment (as % of service exports) of Ethiopia in 2008 and the Balance of Payment (as % of service exports) of Guatemala in 2012?
Provide a short and direct response. 45.75. What is the difference between the Balance of Payment (as % of service exports) of Heavily indebted poor countries in 2009 and the Balance of Payment (as % of service exports) of Aruba in 2010?
Ensure brevity in your answer.  14.03. What is the difference between the Balance of Payment (as % of service exports) of Heavily indebted poor countries in 2009 and the Balance of Payment (as % of service exports) of Ethiopia in 2010?
Your answer should be very brief. -37.04. What is the difference between the Balance of Payment (as % of service exports) in Heavily indebted poor countries in 2009 and the Balance of Payment (as % of service exports) in Guatemala in 2010?
Provide a succinct answer. 4.61. What is the difference between the Balance of Payment (as % of service exports) of Aruba in 2009 and the Balance of Payment (as % of service exports) of Ethiopia in 2010?
Make the answer very short. -50.39. What is the difference between the Balance of Payment (as % of service exports) of Aruba in 2009 and the Balance of Payment (as % of service exports) of Guatemala in 2010?
Provide a short and direct response. -8.74. What is the difference between the Balance of Payment (as % of service exports) of Ethiopia in 2009 and the Balance of Payment (as % of service exports) of Guatemala in 2010?
Provide a short and direct response. 44.45. What is the difference between the Balance of Payment (as % of service exports) of Heavily indebted poor countries in 2009 and the Balance of Payment (as % of service exports) of Aruba in 2011?
Give a very brief answer. 13.48. What is the difference between the Balance of Payment (as % of service exports) in Heavily indebted poor countries in 2009 and the Balance of Payment (as % of service exports) in Ethiopia in 2011?
Provide a succinct answer. -39.44. What is the difference between the Balance of Payment (as % of service exports) in Heavily indebted poor countries in 2009 and the Balance of Payment (as % of service exports) in Guatemala in 2011?
Ensure brevity in your answer.  2.08. What is the difference between the Balance of Payment (as % of service exports) in Aruba in 2009 and the Balance of Payment (as % of service exports) in Ethiopia in 2011?
Provide a short and direct response. -52.79. What is the difference between the Balance of Payment (as % of service exports) of Aruba in 2009 and the Balance of Payment (as % of service exports) of Guatemala in 2011?
Keep it short and to the point. -11.27. What is the difference between the Balance of Payment (as % of service exports) in Ethiopia in 2009 and the Balance of Payment (as % of service exports) in Guatemala in 2011?
Give a very brief answer. 41.92. What is the difference between the Balance of Payment (as % of service exports) in Heavily indebted poor countries in 2009 and the Balance of Payment (as % of service exports) in Aruba in 2012?
Provide a succinct answer. 13.95. What is the difference between the Balance of Payment (as % of service exports) in Heavily indebted poor countries in 2009 and the Balance of Payment (as % of service exports) in Ethiopia in 2012?
Keep it short and to the point. -45.86. What is the difference between the Balance of Payment (as % of service exports) of Heavily indebted poor countries in 2009 and the Balance of Payment (as % of service exports) of Guatemala in 2012?
Your answer should be very brief. 4.09. What is the difference between the Balance of Payment (as % of service exports) in Aruba in 2009 and the Balance of Payment (as % of service exports) in Ethiopia in 2012?
Provide a succinct answer. -59.21. What is the difference between the Balance of Payment (as % of service exports) in Aruba in 2009 and the Balance of Payment (as % of service exports) in Guatemala in 2012?
Offer a terse response. -9.26. What is the difference between the Balance of Payment (as % of service exports) in Ethiopia in 2009 and the Balance of Payment (as % of service exports) in Guatemala in 2012?
Give a very brief answer. 43.93. What is the difference between the Balance of Payment (as % of service exports) in Heavily indebted poor countries in 2010 and the Balance of Payment (as % of service exports) in Aruba in 2011?
Ensure brevity in your answer.  14.46. What is the difference between the Balance of Payment (as % of service exports) in Heavily indebted poor countries in 2010 and the Balance of Payment (as % of service exports) in Ethiopia in 2011?
Keep it short and to the point. -38.45. What is the difference between the Balance of Payment (as % of service exports) of Heavily indebted poor countries in 2010 and the Balance of Payment (as % of service exports) of Guatemala in 2011?
Ensure brevity in your answer.  3.06. What is the difference between the Balance of Payment (as % of service exports) in Aruba in 2010 and the Balance of Payment (as % of service exports) in Ethiopia in 2011?
Make the answer very short. -53.46. What is the difference between the Balance of Payment (as % of service exports) in Aruba in 2010 and the Balance of Payment (as % of service exports) in Guatemala in 2011?
Give a very brief answer. -11.95. What is the difference between the Balance of Payment (as % of service exports) in Ethiopia in 2010 and the Balance of Payment (as % of service exports) in Guatemala in 2011?
Ensure brevity in your answer.  39.11. What is the difference between the Balance of Payment (as % of service exports) of Heavily indebted poor countries in 2010 and the Balance of Payment (as % of service exports) of Aruba in 2012?
Your response must be concise. 14.93. What is the difference between the Balance of Payment (as % of service exports) of Heavily indebted poor countries in 2010 and the Balance of Payment (as % of service exports) of Ethiopia in 2012?
Your answer should be compact. -44.88. What is the difference between the Balance of Payment (as % of service exports) in Heavily indebted poor countries in 2010 and the Balance of Payment (as % of service exports) in Guatemala in 2012?
Your answer should be compact. 5.08. What is the difference between the Balance of Payment (as % of service exports) in Aruba in 2010 and the Balance of Payment (as % of service exports) in Ethiopia in 2012?
Your answer should be compact. -59.89. What is the difference between the Balance of Payment (as % of service exports) of Aruba in 2010 and the Balance of Payment (as % of service exports) of Guatemala in 2012?
Your answer should be compact. -9.94. What is the difference between the Balance of Payment (as % of service exports) of Ethiopia in 2010 and the Balance of Payment (as % of service exports) of Guatemala in 2012?
Your answer should be very brief. 41.13. What is the difference between the Balance of Payment (as % of service exports) in Heavily indebted poor countries in 2011 and the Balance of Payment (as % of service exports) in Aruba in 2012?
Offer a terse response. 17.07. What is the difference between the Balance of Payment (as % of service exports) of Heavily indebted poor countries in 2011 and the Balance of Payment (as % of service exports) of Ethiopia in 2012?
Your answer should be compact. -42.74. What is the difference between the Balance of Payment (as % of service exports) of Heavily indebted poor countries in 2011 and the Balance of Payment (as % of service exports) of Guatemala in 2012?
Give a very brief answer. 7.21. What is the difference between the Balance of Payment (as % of service exports) in Aruba in 2011 and the Balance of Payment (as % of service exports) in Ethiopia in 2012?
Your answer should be very brief. -59.34. What is the difference between the Balance of Payment (as % of service exports) in Aruba in 2011 and the Balance of Payment (as % of service exports) in Guatemala in 2012?
Your answer should be compact. -9.38. What is the difference between the Balance of Payment (as % of service exports) of Ethiopia in 2011 and the Balance of Payment (as % of service exports) of Guatemala in 2012?
Offer a terse response. 43.53. What is the average Balance of Payment (as % of service exports) of Heavily indebted poor countries per year?
Your answer should be very brief. 18.72. What is the average Balance of Payment (as % of service exports) in Aruba per year?
Keep it short and to the point. 3.81. What is the average Balance of Payment (as % of service exports) in Ethiopia per year?
Give a very brief answer. 55.54. What is the average Balance of Payment (as % of service exports) of Guatemala per year?
Make the answer very short. 12.48. In the year 2005, what is the difference between the Balance of Payment (as % of service exports) of Heavily indebted poor countries and Balance of Payment (as % of service exports) of Aruba?
Provide a succinct answer. 13.26. In the year 2005, what is the difference between the Balance of Payment (as % of service exports) of Heavily indebted poor countries and Balance of Payment (as % of service exports) of Ethiopia?
Give a very brief answer. -28.49. In the year 2005, what is the difference between the Balance of Payment (as % of service exports) in Heavily indebted poor countries and Balance of Payment (as % of service exports) in Guatemala?
Provide a succinct answer. 5.78. In the year 2005, what is the difference between the Balance of Payment (as % of service exports) in Aruba and Balance of Payment (as % of service exports) in Ethiopia?
Your answer should be compact. -41.75. In the year 2005, what is the difference between the Balance of Payment (as % of service exports) of Aruba and Balance of Payment (as % of service exports) of Guatemala?
Your answer should be very brief. -7.48. In the year 2005, what is the difference between the Balance of Payment (as % of service exports) in Ethiopia and Balance of Payment (as % of service exports) in Guatemala?
Your answer should be compact. 34.27. In the year 2006, what is the difference between the Balance of Payment (as % of service exports) in Heavily indebted poor countries and Balance of Payment (as % of service exports) in Aruba?
Your answer should be very brief. 14.31. In the year 2006, what is the difference between the Balance of Payment (as % of service exports) of Heavily indebted poor countries and Balance of Payment (as % of service exports) of Ethiopia?
Make the answer very short. -32.75. In the year 2006, what is the difference between the Balance of Payment (as % of service exports) in Heavily indebted poor countries and Balance of Payment (as % of service exports) in Guatemala?
Give a very brief answer. 7.16. In the year 2006, what is the difference between the Balance of Payment (as % of service exports) of Aruba and Balance of Payment (as % of service exports) of Ethiopia?
Make the answer very short. -47.07. In the year 2006, what is the difference between the Balance of Payment (as % of service exports) of Aruba and Balance of Payment (as % of service exports) of Guatemala?
Keep it short and to the point. -7.15. In the year 2006, what is the difference between the Balance of Payment (as % of service exports) in Ethiopia and Balance of Payment (as % of service exports) in Guatemala?
Offer a terse response. 39.92. In the year 2007, what is the difference between the Balance of Payment (as % of service exports) in Heavily indebted poor countries and Balance of Payment (as % of service exports) in Aruba?
Ensure brevity in your answer.  14.29. In the year 2007, what is the difference between the Balance of Payment (as % of service exports) in Heavily indebted poor countries and Balance of Payment (as % of service exports) in Ethiopia?
Offer a very short reply. -38.29. In the year 2007, what is the difference between the Balance of Payment (as % of service exports) in Heavily indebted poor countries and Balance of Payment (as % of service exports) in Guatemala?
Keep it short and to the point. 7.1. In the year 2007, what is the difference between the Balance of Payment (as % of service exports) in Aruba and Balance of Payment (as % of service exports) in Ethiopia?
Your answer should be compact. -52.58. In the year 2007, what is the difference between the Balance of Payment (as % of service exports) in Aruba and Balance of Payment (as % of service exports) in Guatemala?
Your response must be concise. -7.19. In the year 2007, what is the difference between the Balance of Payment (as % of service exports) of Ethiopia and Balance of Payment (as % of service exports) of Guatemala?
Offer a very short reply. 45.39. In the year 2008, what is the difference between the Balance of Payment (as % of service exports) of Heavily indebted poor countries and Balance of Payment (as % of service exports) of Ethiopia?
Your answer should be compact. -41.32. In the year 2008, what is the difference between the Balance of Payment (as % of service exports) of Heavily indebted poor countries and Balance of Payment (as % of service exports) of Guatemala?
Offer a terse response. 5.63. In the year 2008, what is the difference between the Balance of Payment (as % of service exports) in Aruba and Balance of Payment (as % of service exports) in Ethiopia?
Offer a terse response. -55.42. In the year 2008, what is the difference between the Balance of Payment (as % of service exports) of Aruba and Balance of Payment (as % of service exports) of Guatemala?
Make the answer very short. -8.47. In the year 2008, what is the difference between the Balance of Payment (as % of service exports) of Ethiopia and Balance of Payment (as % of service exports) of Guatemala?
Provide a succinct answer. 46.95. In the year 2009, what is the difference between the Balance of Payment (as % of service exports) of Heavily indebted poor countries and Balance of Payment (as % of service exports) of Aruba?
Make the answer very short. 13.35. In the year 2009, what is the difference between the Balance of Payment (as % of service exports) of Heavily indebted poor countries and Balance of Payment (as % of service exports) of Ethiopia?
Your response must be concise. -39.84. In the year 2009, what is the difference between the Balance of Payment (as % of service exports) in Heavily indebted poor countries and Balance of Payment (as % of service exports) in Guatemala?
Your answer should be compact. 4.98. In the year 2009, what is the difference between the Balance of Payment (as % of service exports) of Aruba and Balance of Payment (as % of service exports) of Ethiopia?
Offer a very short reply. -53.19. In the year 2009, what is the difference between the Balance of Payment (as % of service exports) in Aruba and Balance of Payment (as % of service exports) in Guatemala?
Give a very brief answer. -8.37. In the year 2009, what is the difference between the Balance of Payment (as % of service exports) of Ethiopia and Balance of Payment (as % of service exports) of Guatemala?
Provide a succinct answer. 44.82. In the year 2010, what is the difference between the Balance of Payment (as % of service exports) in Heavily indebted poor countries and Balance of Payment (as % of service exports) in Aruba?
Your answer should be very brief. 15.01. In the year 2010, what is the difference between the Balance of Payment (as % of service exports) in Heavily indebted poor countries and Balance of Payment (as % of service exports) in Ethiopia?
Your answer should be very brief. -36.05. In the year 2010, what is the difference between the Balance of Payment (as % of service exports) of Heavily indebted poor countries and Balance of Payment (as % of service exports) of Guatemala?
Make the answer very short. 5.59. In the year 2010, what is the difference between the Balance of Payment (as % of service exports) in Aruba and Balance of Payment (as % of service exports) in Ethiopia?
Offer a terse response. -51.07. In the year 2010, what is the difference between the Balance of Payment (as % of service exports) in Aruba and Balance of Payment (as % of service exports) in Guatemala?
Ensure brevity in your answer.  -9.42. In the year 2010, what is the difference between the Balance of Payment (as % of service exports) of Ethiopia and Balance of Payment (as % of service exports) of Guatemala?
Your answer should be very brief. 41.65. In the year 2011, what is the difference between the Balance of Payment (as % of service exports) in Heavily indebted poor countries and Balance of Payment (as % of service exports) in Aruba?
Your response must be concise. 16.6. In the year 2011, what is the difference between the Balance of Payment (as % of service exports) in Heavily indebted poor countries and Balance of Payment (as % of service exports) in Ethiopia?
Offer a very short reply. -36.32. In the year 2011, what is the difference between the Balance of Payment (as % of service exports) in Heavily indebted poor countries and Balance of Payment (as % of service exports) in Guatemala?
Ensure brevity in your answer.  5.2. In the year 2011, what is the difference between the Balance of Payment (as % of service exports) of Aruba and Balance of Payment (as % of service exports) of Ethiopia?
Give a very brief answer. -52.91. In the year 2011, what is the difference between the Balance of Payment (as % of service exports) in Aruba and Balance of Payment (as % of service exports) in Guatemala?
Offer a terse response. -11.4. In the year 2011, what is the difference between the Balance of Payment (as % of service exports) in Ethiopia and Balance of Payment (as % of service exports) in Guatemala?
Your answer should be very brief. 41.51. In the year 2012, what is the difference between the Balance of Payment (as % of service exports) of Heavily indebted poor countries and Balance of Payment (as % of service exports) of Aruba?
Provide a succinct answer. 18.38. In the year 2012, what is the difference between the Balance of Payment (as % of service exports) of Heavily indebted poor countries and Balance of Payment (as % of service exports) of Ethiopia?
Provide a short and direct response. -41.43. In the year 2012, what is the difference between the Balance of Payment (as % of service exports) in Heavily indebted poor countries and Balance of Payment (as % of service exports) in Guatemala?
Provide a succinct answer. 8.53. In the year 2012, what is the difference between the Balance of Payment (as % of service exports) in Aruba and Balance of Payment (as % of service exports) in Ethiopia?
Make the answer very short. -59.81. In the year 2012, what is the difference between the Balance of Payment (as % of service exports) in Aruba and Balance of Payment (as % of service exports) in Guatemala?
Give a very brief answer. -9.86. In the year 2012, what is the difference between the Balance of Payment (as % of service exports) in Ethiopia and Balance of Payment (as % of service exports) in Guatemala?
Offer a very short reply. 49.95. What is the ratio of the Balance of Payment (as % of service exports) of Heavily indebted poor countries in 2005 to that in 2006?
Ensure brevity in your answer.  0.96. What is the ratio of the Balance of Payment (as % of service exports) of Aruba in 2005 to that in 2006?
Your answer should be very brief. 1.06. What is the ratio of the Balance of Payment (as % of service exports) in Ethiopia in 2005 to that in 2006?
Ensure brevity in your answer.  0.9. What is the ratio of the Balance of Payment (as % of service exports) in Guatemala in 2005 to that in 2006?
Your response must be concise. 1.05. What is the ratio of the Balance of Payment (as % of service exports) in Heavily indebted poor countries in 2005 to that in 2007?
Offer a terse response. 0.97. What is the ratio of the Balance of Payment (as % of service exports) of Aruba in 2005 to that in 2007?
Your response must be concise. 1.12. What is the ratio of the Balance of Payment (as % of service exports) of Ethiopia in 2005 to that in 2007?
Provide a succinct answer. 0.82. What is the ratio of the Balance of Payment (as % of service exports) of Guatemala in 2005 to that in 2007?
Provide a short and direct response. 1.07. What is the ratio of the Balance of Payment (as % of service exports) of Aruba in 2005 to that in 2008?
Your answer should be very brief. 1.21. What is the ratio of the Balance of Payment (as % of service exports) of Ethiopia in 2005 to that in 2008?
Offer a very short reply. 0.78. What is the ratio of the Balance of Payment (as % of service exports) in Guatemala in 2005 to that in 2008?
Offer a terse response. 0.98. What is the ratio of the Balance of Payment (as % of service exports) in Heavily indebted poor countries in 2005 to that in 2009?
Give a very brief answer. 1.01. What is the ratio of the Balance of Payment (as % of service exports) in Aruba in 2005 to that in 2009?
Your response must be concise. 1.08. What is the ratio of the Balance of Payment (as % of service exports) of Ethiopia in 2005 to that in 2009?
Offer a terse response. 0.81. What is the ratio of the Balance of Payment (as % of service exports) in Guatemala in 2005 to that in 2009?
Make the answer very short. 0.95. What is the ratio of the Balance of Payment (as % of service exports) in Heavily indebted poor countries in 2005 to that in 2010?
Your response must be concise. 0.96. What is the ratio of the Balance of Payment (as % of service exports) in Aruba in 2005 to that in 2010?
Provide a succinct answer. 1.3. What is the ratio of the Balance of Payment (as % of service exports) of Ethiopia in 2005 to that in 2010?
Your response must be concise. 0.85. What is the ratio of the Balance of Payment (as % of service exports) of Guatemala in 2005 to that in 2010?
Your response must be concise. 0.93. What is the ratio of the Balance of Payment (as % of service exports) in Heavily indebted poor countries in 2005 to that in 2011?
Offer a very short reply. 0.86. What is the ratio of the Balance of Payment (as % of service exports) in Aruba in 2005 to that in 2011?
Your answer should be compact. 1.12. What is the ratio of the Balance of Payment (as % of service exports) of Ethiopia in 2005 to that in 2011?
Offer a very short reply. 0.81. What is the ratio of the Balance of Payment (as % of service exports) of Guatemala in 2005 to that in 2011?
Offer a very short reply. 0.77. What is the ratio of the Balance of Payment (as % of service exports) in Heavily indebted poor countries in 2005 to that in 2012?
Keep it short and to the point. 0.81. What is the ratio of the Balance of Payment (as % of service exports) of Aruba in 2005 to that in 2012?
Offer a terse response. 1.27. What is the ratio of the Balance of Payment (as % of service exports) in Ethiopia in 2005 to that in 2012?
Offer a very short reply. 0.73. What is the ratio of the Balance of Payment (as % of service exports) in Guatemala in 2005 to that in 2012?
Make the answer very short. 0.89. What is the ratio of the Balance of Payment (as % of service exports) of Heavily indebted poor countries in 2006 to that in 2007?
Provide a short and direct response. 1.01. What is the ratio of the Balance of Payment (as % of service exports) of Aruba in 2006 to that in 2007?
Give a very brief answer. 1.06. What is the ratio of the Balance of Payment (as % of service exports) of Ethiopia in 2006 to that in 2007?
Provide a short and direct response. 0.91. What is the ratio of the Balance of Payment (as % of service exports) in Guatemala in 2006 to that in 2007?
Make the answer very short. 1.02. What is the ratio of the Balance of Payment (as % of service exports) of Heavily indebted poor countries in 2006 to that in 2008?
Offer a terse response. 1.04. What is the ratio of the Balance of Payment (as % of service exports) of Aruba in 2006 to that in 2008?
Your answer should be compact. 1.14. What is the ratio of the Balance of Payment (as % of service exports) in Ethiopia in 2006 to that in 2008?
Keep it short and to the point. 0.87. What is the ratio of the Balance of Payment (as % of service exports) of Guatemala in 2006 to that in 2008?
Offer a very short reply. 0.93. What is the ratio of the Balance of Payment (as % of service exports) of Heavily indebted poor countries in 2006 to that in 2009?
Offer a very short reply. 1.06. What is the ratio of the Balance of Payment (as % of service exports) of Aruba in 2006 to that in 2009?
Provide a short and direct response. 1.02. What is the ratio of the Balance of Payment (as % of service exports) of Ethiopia in 2006 to that in 2009?
Your answer should be compact. 0.89. What is the ratio of the Balance of Payment (as % of service exports) in Guatemala in 2006 to that in 2009?
Provide a succinct answer. 0.91. What is the ratio of the Balance of Payment (as % of service exports) of Heavily indebted poor countries in 2006 to that in 2010?
Provide a short and direct response. 1. What is the ratio of the Balance of Payment (as % of service exports) of Aruba in 2006 to that in 2010?
Give a very brief answer. 1.23. What is the ratio of the Balance of Payment (as % of service exports) in Ethiopia in 2006 to that in 2010?
Your answer should be compact. 0.94. What is the ratio of the Balance of Payment (as % of service exports) in Guatemala in 2006 to that in 2010?
Your response must be concise. 0.88. What is the ratio of the Balance of Payment (as % of service exports) of Heavily indebted poor countries in 2006 to that in 2011?
Keep it short and to the point. 0.9. What is the ratio of the Balance of Payment (as % of service exports) in Aruba in 2006 to that in 2011?
Your answer should be compact. 1.05. What is the ratio of the Balance of Payment (as % of service exports) in Ethiopia in 2006 to that in 2011?
Keep it short and to the point. 0.9. What is the ratio of the Balance of Payment (as % of service exports) in Guatemala in 2006 to that in 2011?
Provide a succinct answer. 0.74. What is the ratio of the Balance of Payment (as % of service exports) in Heavily indebted poor countries in 2006 to that in 2012?
Provide a succinct answer. 0.84. What is the ratio of the Balance of Payment (as % of service exports) in Aruba in 2006 to that in 2012?
Offer a terse response. 1.2. What is the ratio of the Balance of Payment (as % of service exports) in Ethiopia in 2006 to that in 2012?
Make the answer very short. 0.81. What is the ratio of the Balance of Payment (as % of service exports) in Guatemala in 2006 to that in 2012?
Your answer should be very brief. 0.85. What is the ratio of the Balance of Payment (as % of service exports) of Heavily indebted poor countries in 2007 to that in 2008?
Your answer should be compact. 1.03. What is the ratio of the Balance of Payment (as % of service exports) of Aruba in 2007 to that in 2008?
Offer a terse response. 1.08. What is the ratio of the Balance of Payment (as % of service exports) in Ethiopia in 2007 to that in 2008?
Offer a very short reply. 0.96. What is the ratio of the Balance of Payment (as % of service exports) in Guatemala in 2007 to that in 2008?
Make the answer very short. 0.92. What is the ratio of the Balance of Payment (as % of service exports) in Heavily indebted poor countries in 2007 to that in 2009?
Keep it short and to the point. 1.05. What is the ratio of the Balance of Payment (as % of service exports) in Ethiopia in 2007 to that in 2009?
Make the answer very short. 0.99. What is the ratio of the Balance of Payment (as % of service exports) in Guatemala in 2007 to that in 2009?
Your answer should be compact. 0.89. What is the ratio of the Balance of Payment (as % of service exports) of Heavily indebted poor countries in 2007 to that in 2010?
Provide a short and direct response. 0.99. What is the ratio of the Balance of Payment (as % of service exports) of Aruba in 2007 to that in 2010?
Offer a terse response. 1.16. What is the ratio of the Balance of Payment (as % of service exports) in Ethiopia in 2007 to that in 2010?
Offer a terse response. 1.04. What is the ratio of the Balance of Payment (as % of service exports) of Guatemala in 2007 to that in 2010?
Offer a terse response. 0.87. What is the ratio of the Balance of Payment (as % of service exports) in Heavily indebted poor countries in 2007 to that in 2011?
Make the answer very short. 0.89. What is the ratio of the Balance of Payment (as % of service exports) in Guatemala in 2007 to that in 2011?
Offer a very short reply. 0.72. What is the ratio of the Balance of Payment (as % of service exports) in Heavily indebted poor countries in 2007 to that in 2012?
Your answer should be very brief. 0.83. What is the ratio of the Balance of Payment (as % of service exports) of Aruba in 2007 to that in 2012?
Keep it short and to the point. 1.13. What is the ratio of the Balance of Payment (as % of service exports) of Ethiopia in 2007 to that in 2012?
Give a very brief answer. 0.89. What is the ratio of the Balance of Payment (as % of service exports) in Guatemala in 2007 to that in 2012?
Your answer should be very brief. 0.83. What is the ratio of the Balance of Payment (as % of service exports) in Heavily indebted poor countries in 2008 to that in 2009?
Your response must be concise. 1.02. What is the ratio of the Balance of Payment (as % of service exports) of Aruba in 2008 to that in 2009?
Keep it short and to the point. 0.9. What is the ratio of the Balance of Payment (as % of service exports) of Ethiopia in 2008 to that in 2009?
Your answer should be compact. 1.03. What is the ratio of the Balance of Payment (as % of service exports) of Guatemala in 2008 to that in 2009?
Keep it short and to the point. 0.97. What is the ratio of the Balance of Payment (as % of service exports) of Heavily indebted poor countries in 2008 to that in 2010?
Your answer should be very brief. 0.96. What is the ratio of the Balance of Payment (as % of service exports) in Aruba in 2008 to that in 2010?
Keep it short and to the point. 1.08. What is the ratio of the Balance of Payment (as % of service exports) in Ethiopia in 2008 to that in 2010?
Provide a succinct answer. 1.08. What is the ratio of the Balance of Payment (as % of service exports) in Guatemala in 2008 to that in 2010?
Keep it short and to the point. 0.95. What is the ratio of the Balance of Payment (as % of service exports) in Heavily indebted poor countries in 2008 to that in 2011?
Your answer should be compact. 0.86. What is the ratio of the Balance of Payment (as % of service exports) in Aruba in 2008 to that in 2011?
Keep it short and to the point. 0.93. What is the ratio of the Balance of Payment (as % of service exports) in Ethiopia in 2008 to that in 2011?
Provide a short and direct response. 1.04. What is the ratio of the Balance of Payment (as % of service exports) of Guatemala in 2008 to that in 2011?
Offer a terse response. 0.79. What is the ratio of the Balance of Payment (as % of service exports) of Heavily indebted poor countries in 2008 to that in 2012?
Your response must be concise. 0.81. What is the ratio of the Balance of Payment (as % of service exports) in Aruba in 2008 to that in 2012?
Provide a short and direct response. 1.05. What is the ratio of the Balance of Payment (as % of service exports) in Ethiopia in 2008 to that in 2012?
Ensure brevity in your answer.  0.93. What is the ratio of the Balance of Payment (as % of service exports) in Guatemala in 2008 to that in 2012?
Your answer should be very brief. 0.91. What is the ratio of the Balance of Payment (as % of service exports) in Heavily indebted poor countries in 2009 to that in 2010?
Your answer should be very brief. 0.95. What is the ratio of the Balance of Payment (as % of service exports) of Aruba in 2009 to that in 2010?
Provide a short and direct response. 1.2. What is the ratio of the Balance of Payment (as % of service exports) of Ethiopia in 2009 to that in 2010?
Make the answer very short. 1.05. What is the ratio of the Balance of Payment (as % of service exports) of Guatemala in 2009 to that in 2010?
Offer a very short reply. 0.97. What is the ratio of the Balance of Payment (as % of service exports) of Heavily indebted poor countries in 2009 to that in 2011?
Ensure brevity in your answer.  0.85. What is the ratio of the Balance of Payment (as % of service exports) in Aruba in 2009 to that in 2011?
Offer a terse response. 1.03. What is the ratio of the Balance of Payment (as % of service exports) of Ethiopia in 2009 to that in 2011?
Offer a terse response. 1.01. What is the ratio of the Balance of Payment (as % of service exports) of Guatemala in 2009 to that in 2011?
Keep it short and to the point. 0.81. What is the ratio of the Balance of Payment (as % of service exports) in Heavily indebted poor countries in 2009 to that in 2012?
Keep it short and to the point. 0.8. What is the ratio of the Balance of Payment (as % of service exports) of Aruba in 2009 to that in 2012?
Offer a very short reply. 1.18. What is the ratio of the Balance of Payment (as % of service exports) of Ethiopia in 2009 to that in 2012?
Ensure brevity in your answer.  0.9. What is the ratio of the Balance of Payment (as % of service exports) in Guatemala in 2009 to that in 2012?
Provide a succinct answer. 0.93. What is the ratio of the Balance of Payment (as % of service exports) in Heavily indebted poor countries in 2010 to that in 2011?
Make the answer very short. 0.9. What is the ratio of the Balance of Payment (as % of service exports) of Aruba in 2010 to that in 2011?
Provide a succinct answer. 0.86. What is the ratio of the Balance of Payment (as % of service exports) of Ethiopia in 2010 to that in 2011?
Provide a succinct answer. 0.96. What is the ratio of the Balance of Payment (as % of service exports) of Guatemala in 2010 to that in 2011?
Provide a short and direct response. 0.83. What is the ratio of the Balance of Payment (as % of service exports) in Heavily indebted poor countries in 2010 to that in 2012?
Offer a very short reply. 0.84. What is the ratio of the Balance of Payment (as % of service exports) of Aruba in 2010 to that in 2012?
Ensure brevity in your answer.  0.98. What is the ratio of the Balance of Payment (as % of service exports) in Ethiopia in 2010 to that in 2012?
Provide a succinct answer. 0.86. What is the ratio of the Balance of Payment (as % of service exports) in Guatemala in 2010 to that in 2012?
Offer a terse response. 0.96. What is the ratio of the Balance of Payment (as % of service exports) of Heavily indebted poor countries in 2011 to that in 2012?
Provide a short and direct response. 0.94. What is the ratio of the Balance of Payment (as % of service exports) in Aruba in 2011 to that in 2012?
Provide a succinct answer. 1.14. What is the ratio of the Balance of Payment (as % of service exports) of Ethiopia in 2011 to that in 2012?
Your answer should be very brief. 0.9. What is the ratio of the Balance of Payment (as % of service exports) in Guatemala in 2011 to that in 2012?
Your answer should be compact. 1.15. What is the difference between the highest and the second highest Balance of Payment (as % of service exports) in Heavily indebted poor countries?
Your answer should be very brief. 1.31. What is the difference between the highest and the second highest Balance of Payment (as % of service exports) in Aruba?
Provide a succinct answer. 0.24. What is the difference between the highest and the second highest Balance of Payment (as % of service exports) of Ethiopia?
Your answer should be compact. 4.2. What is the difference between the highest and the second highest Balance of Payment (as % of service exports) in Guatemala?
Provide a succinct answer. 2.02. What is the difference between the highest and the lowest Balance of Payment (as % of service exports) of Heavily indebted poor countries?
Your answer should be compact. 4.43. What is the difference between the highest and the lowest Balance of Payment (as % of service exports) of Aruba?
Keep it short and to the point. 1. What is the difference between the highest and the lowest Balance of Payment (as % of service exports) in Ethiopia?
Make the answer very short. 17.14. What is the difference between the highest and the lowest Balance of Payment (as % of service exports) in Guatemala?
Provide a short and direct response. 4.22. 